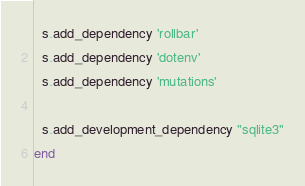Convert code to text. <code><loc_0><loc_0><loc_500><loc_500><_Ruby_>  s.add_dependency 'rollbar'
  s.add_dependency 'dotenv'
  s.add_dependency 'mutations'

  s.add_development_dependency "sqlite3"
end
</code> 